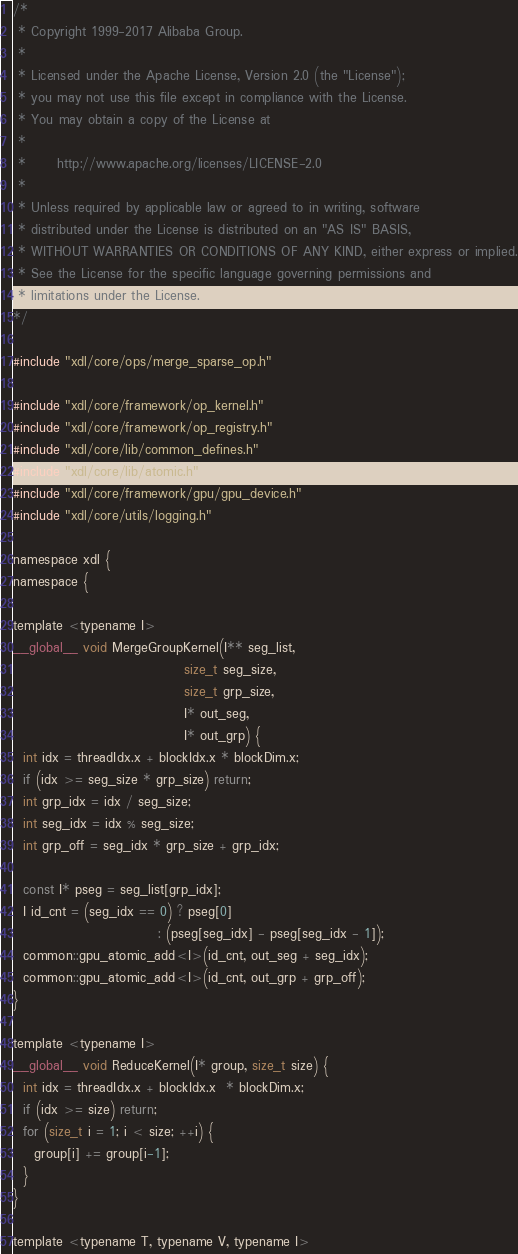<code> <loc_0><loc_0><loc_500><loc_500><_Cuda_>/*
 * Copyright 1999-2017 Alibaba Group.
 *
 * Licensed under the Apache License, Version 2.0 (the "License");
 * you may not use this file except in compliance with the License.
 * You may obtain a copy of the License at
 *
 *      http://www.apache.org/licenses/LICENSE-2.0
 *
 * Unless required by applicable law or agreed to in writing, software
 * distributed under the License is distributed on an "AS IS" BASIS,
 * WITHOUT WARRANTIES OR CONDITIONS OF ANY KIND, either express or implied.
 * See the License for the specific language governing permissions and
 * limitations under the License.
*/

#include "xdl/core/ops/merge_sparse_op.h"

#include "xdl/core/framework/op_kernel.h"
#include "xdl/core/framework/op_registry.h"
#include "xdl/core/lib/common_defines.h"
#include "xdl/core/lib/atomic.h"
#include "xdl/core/framework/gpu/gpu_device.h"
#include "xdl/core/utils/logging.h"

namespace xdl {
namespace {

template <typename I>
__global__ void MergeGroupKernel(I** seg_list,
                                 size_t seg_size,
                                 size_t grp_size,
                                 I* out_seg,
                                 I* out_grp) {
  int idx = threadIdx.x + blockIdx.x * blockDim.x;
  if (idx >= seg_size * grp_size) return;
  int grp_idx = idx / seg_size;
  int seg_idx = idx % seg_size;
  int grp_off = seg_idx * grp_size + grp_idx;

  const I* pseg = seg_list[grp_idx];
  I id_cnt = (seg_idx == 0) ? pseg[0] 
                            : (pseg[seg_idx] - pseg[seg_idx - 1]);
  common::gpu_atomic_add<I>(id_cnt, out_seg + seg_idx);
  common::gpu_atomic_add<I>(id_cnt, out_grp + grp_off);
}

template <typename I>
__global__ void ReduceKernel(I* group, size_t size) {
  int idx = threadIdx.x + blockIdx.x  * blockDim.x;
  if (idx >= size) return;
  for (size_t i = 1; i < size; ++i) {
    group[i] += group[i-1];
  }
}

template <typename T, typename V, typename I></code> 